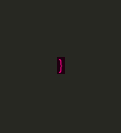<code> <loc_0><loc_0><loc_500><loc_500><_CSS_>}
</code> 